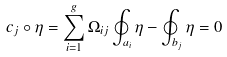Convert formula to latex. <formula><loc_0><loc_0><loc_500><loc_500>c _ { j } \circ \eta = \sum ^ { g } _ { i = 1 } \Omega _ { i j } \oint _ { a _ { i } } \eta - \oint _ { b _ { j } } \eta = 0</formula> 